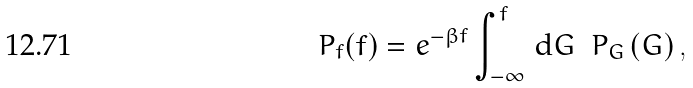<formula> <loc_0><loc_0><loc_500><loc_500>P _ { f } ( f ) = e ^ { - \beta f } \int _ { - \infty } ^ { f } \, \text {d} G \ \ P _ { G } \left ( G \right ) ,</formula> 